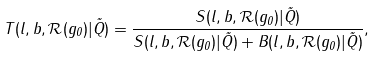<formula> <loc_0><loc_0><loc_500><loc_500>T ( l , b , \mathcal { R } ( g _ { 0 } ) | \vec { Q } ) = \frac { S ( l , b , \mathcal { R } ( g _ { 0 } ) | \vec { Q } ) } { S ( l , b , \mathcal { R } ( g _ { 0 } ) | \vec { Q } ) + B ( l , b , \mathcal { R } ( g _ { 0 } ) | \vec { Q } ) } ,</formula> 